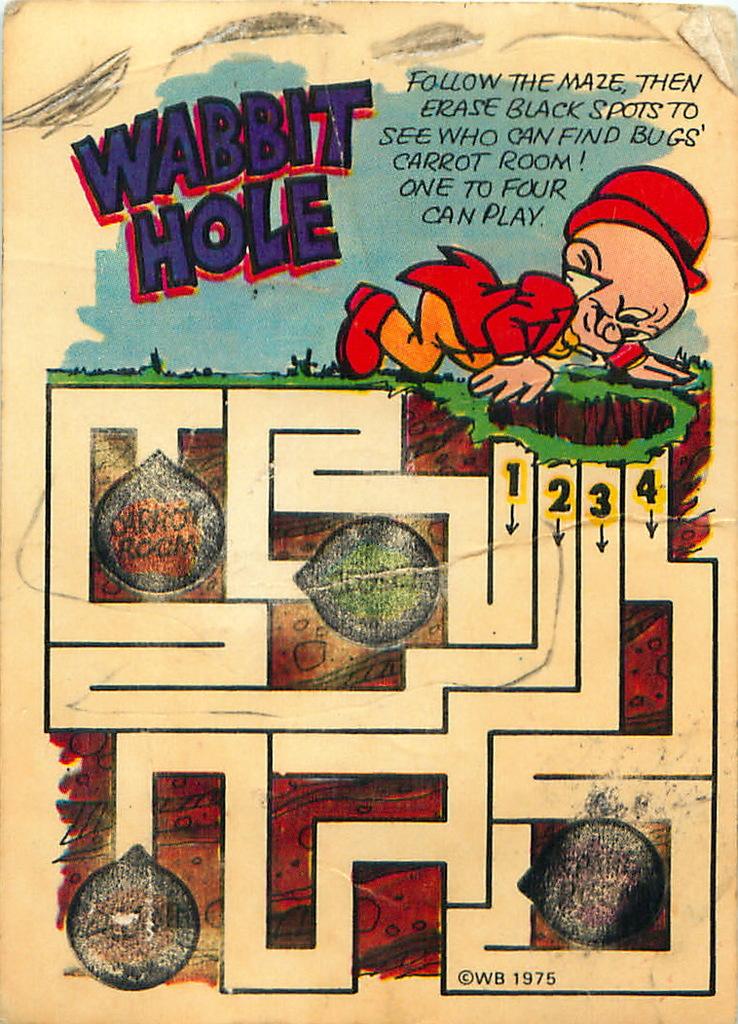Can you complete the maze?
Ensure brevity in your answer.  Answering does not require reading text in the image. What is the name of this maze?
Ensure brevity in your answer.  Wabbit hole. 